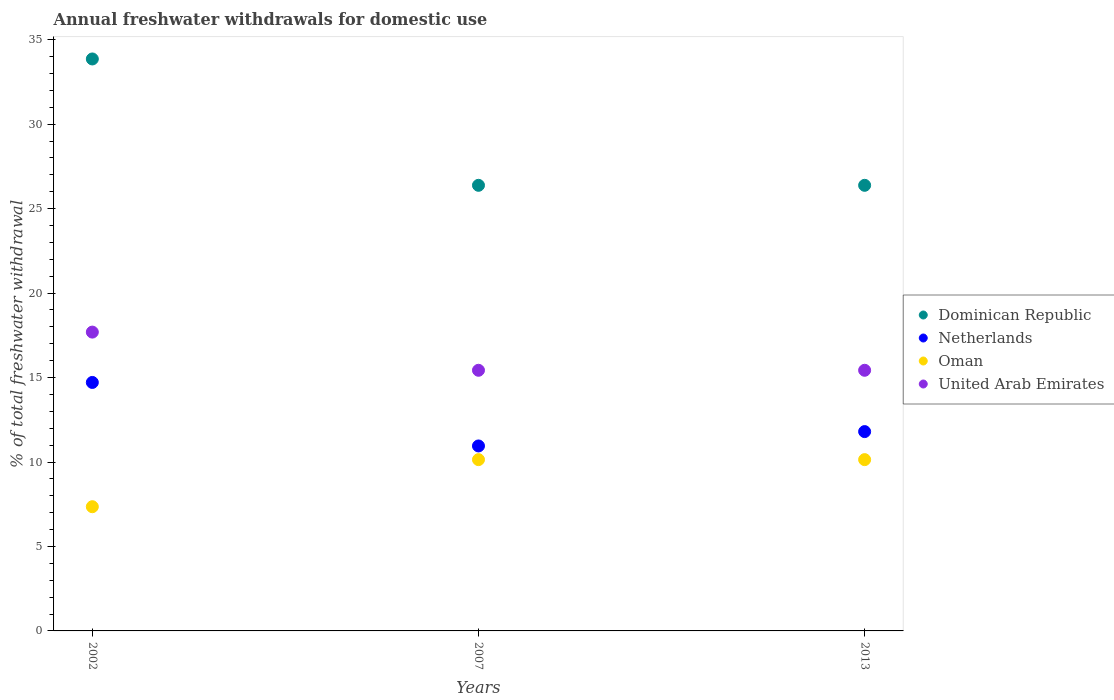Is the number of dotlines equal to the number of legend labels?
Keep it short and to the point. Yes. Across all years, what is the maximum total annual withdrawals from freshwater in Dominican Republic?
Ensure brevity in your answer.  33.86. Across all years, what is the minimum total annual withdrawals from freshwater in Dominican Republic?
Provide a short and direct response. 26.38. In which year was the total annual withdrawals from freshwater in Netherlands minimum?
Offer a very short reply. 2007. What is the total total annual withdrawals from freshwater in Oman in the graph?
Provide a short and direct response. 27.63. What is the difference between the total annual withdrawals from freshwater in Oman in 2002 and that in 2007?
Your answer should be very brief. -2.79. What is the difference between the total annual withdrawals from freshwater in United Arab Emirates in 2013 and the total annual withdrawals from freshwater in Dominican Republic in 2007?
Give a very brief answer. -10.95. What is the average total annual withdrawals from freshwater in United Arab Emirates per year?
Offer a very short reply. 16.18. In the year 2013, what is the difference between the total annual withdrawals from freshwater in United Arab Emirates and total annual withdrawals from freshwater in Dominican Republic?
Offer a very short reply. -10.95. What is the ratio of the total annual withdrawals from freshwater in Oman in 2002 to that in 2013?
Your response must be concise. 0.73. What is the difference between the highest and the second highest total annual withdrawals from freshwater in Netherlands?
Ensure brevity in your answer.  2.91. What is the difference between the highest and the lowest total annual withdrawals from freshwater in Dominican Republic?
Offer a terse response. 7.48. In how many years, is the total annual withdrawals from freshwater in Dominican Republic greater than the average total annual withdrawals from freshwater in Dominican Republic taken over all years?
Offer a terse response. 1. Is the sum of the total annual withdrawals from freshwater in Netherlands in 2002 and 2007 greater than the maximum total annual withdrawals from freshwater in United Arab Emirates across all years?
Provide a short and direct response. Yes. Does the total annual withdrawals from freshwater in Oman monotonically increase over the years?
Your response must be concise. No. Is the total annual withdrawals from freshwater in Dominican Republic strictly less than the total annual withdrawals from freshwater in Oman over the years?
Offer a very short reply. No. How many dotlines are there?
Ensure brevity in your answer.  4. Are the values on the major ticks of Y-axis written in scientific E-notation?
Offer a terse response. No. Does the graph contain any zero values?
Your answer should be compact. No. Where does the legend appear in the graph?
Your answer should be compact. Center right. How many legend labels are there?
Keep it short and to the point. 4. What is the title of the graph?
Your response must be concise. Annual freshwater withdrawals for domestic use. What is the label or title of the X-axis?
Your answer should be compact. Years. What is the label or title of the Y-axis?
Ensure brevity in your answer.  % of total freshwater withdrawal. What is the % of total freshwater withdrawal in Dominican Republic in 2002?
Provide a short and direct response. 33.86. What is the % of total freshwater withdrawal of Netherlands in 2002?
Keep it short and to the point. 14.71. What is the % of total freshwater withdrawal in Oman in 2002?
Make the answer very short. 7.35. What is the % of total freshwater withdrawal of United Arab Emirates in 2002?
Give a very brief answer. 17.69. What is the % of total freshwater withdrawal in Dominican Republic in 2007?
Provide a short and direct response. 26.38. What is the % of total freshwater withdrawal in Netherlands in 2007?
Offer a terse response. 10.95. What is the % of total freshwater withdrawal of Oman in 2007?
Provide a short and direct response. 10.14. What is the % of total freshwater withdrawal of United Arab Emirates in 2007?
Make the answer very short. 15.43. What is the % of total freshwater withdrawal in Dominican Republic in 2013?
Provide a short and direct response. 26.38. What is the % of total freshwater withdrawal in Netherlands in 2013?
Offer a very short reply. 11.8. What is the % of total freshwater withdrawal of Oman in 2013?
Your answer should be compact. 10.14. What is the % of total freshwater withdrawal in United Arab Emirates in 2013?
Make the answer very short. 15.43. Across all years, what is the maximum % of total freshwater withdrawal of Dominican Republic?
Keep it short and to the point. 33.86. Across all years, what is the maximum % of total freshwater withdrawal in Netherlands?
Make the answer very short. 14.71. Across all years, what is the maximum % of total freshwater withdrawal of Oman?
Ensure brevity in your answer.  10.14. Across all years, what is the maximum % of total freshwater withdrawal in United Arab Emirates?
Ensure brevity in your answer.  17.69. Across all years, what is the minimum % of total freshwater withdrawal in Dominican Republic?
Offer a very short reply. 26.38. Across all years, what is the minimum % of total freshwater withdrawal in Netherlands?
Ensure brevity in your answer.  10.95. Across all years, what is the minimum % of total freshwater withdrawal of Oman?
Your response must be concise. 7.35. Across all years, what is the minimum % of total freshwater withdrawal in United Arab Emirates?
Give a very brief answer. 15.43. What is the total % of total freshwater withdrawal in Dominican Republic in the graph?
Provide a succinct answer. 86.62. What is the total % of total freshwater withdrawal in Netherlands in the graph?
Ensure brevity in your answer.  37.46. What is the total % of total freshwater withdrawal of Oman in the graph?
Offer a very short reply. 27.63. What is the total % of total freshwater withdrawal in United Arab Emirates in the graph?
Offer a very short reply. 48.55. What is the difference between the % of total freshwater withdrawal of Dominican Republic in 2002 and that in 2007?
Make the answer very short. 7.48. What is the difference between the % of total freshwater withdrawal in Netherlands in 2002 and that in 2007?
Make the answer very short. 3.76. What is the difference between the % of total freshwater withdrawal in Oman in 2002 and that in 2007?
Your answer should be compact. -2.79. What is the difference between the % of total freshwater withdrawal in United Arab Emirates in 2002 and that in 2007?
Keep it short and to the point. 2.26. What is the difference between the % of total freshwater withdrawal of Dominican Republic in 2002 and that in 2013?
Your answer should be very brief. 7.48. What is the difference between the % of total freshwater withdrawal of Netherlands in 2002 and that in 2013?
Give a very brief answer. 2.91. What is the difference between the % of total freshwater withdrawal in Oman in 2002 and that in 2013?
Offer a terse response. -2.79. What is the difference between the % of total freshwater withdrawal of United Arab Emirates in 2002 and that in 2013?
Offer a terse response. 2.26. What is the difference between the % of total freshwater withdrawal in Netherlands in 2007 and that in 2013?
Make the answer very short. -0.85. What is the difference between the % of total freshwater withdrawal in United Arab Emirates in 2007 and that in 2013?
Your response must be concise. 0. What is the difference between the % of total freshwater withdrawal in Dominican Republic in 2002 and the % of total freshwater withdrawal in Netherlands in 2007?
Provide a succinct answer. 22.91. What is the difference between the % of total freshwater withdrawal of Dominican Republic in 2002 and the % of total freshwater withdrawal of Oman in 2007?
Your response must be concise. 23.72. What is the difference between the % of total freshwater withdrawal in Dominican Republic in 2002 and the % of total freshwater withdrawal in United Arab Emirates in 2007?
Keep it short and to the point. 18.43. What is the difference between the % of total freshwater withdrawal in Netherlands in 2002 and the % of total freshwater withdrawal in Oman in 2007?
Make the answer very short. 4.57. What is the difference between the % of total freshwater withdrawal of Netherlands in 2002 and the % of total freshwater withdrawal of United Arab Emirates in 2007?
Make the answer very short. -0.72. What is the difference between the % of total freshwater withdrawal of Oman in 2002 and the % of total freshwater withdrawal of United Arab Emirates in 2007?
Give a very brief answer. -8.08. What is the difference between the % of total freshwater withdrawal of Dominican Republic in 2002 and the % of total freshwater withdrawal of Netherlands in 2013?
Make the answer very short. 22.06. What is the difference between the % of total freshwater withdrawal of Dominican Republic in 2002 and the % of total freshwater withdrawal of Oman in 2013?
Keep it short and to the point. 23.72. What is the difference between the % of total freshwater withdrawal in Dominican Republic in 2002 and the % of total freshwater withdrawal in United Arab Emirates in 2013?
Provide a succinct answer. 18.43. What is the difference between the % of total freshwater withdrawal of Netherlands in 2002 and the % of total freshwater withdrawal of Oman in 2013?
Provide a succinct answer. 4.57. What is the difference between the % of total freshwater withdrawal in Netherlands in 2002 and the % of total freshwater withdrawal in United Arab Emirates in 2013?
Provide a short and direct response. -0.72. What is the difference between the % of total freshwater withdrawal of Oman in 2002 and the % of total freshwater withdrawal of United Arab Emirates in 2013?
Offer a terse response. -8.08. What is the difference between the % of total freshwater withdrawal in Dominican Republic in 2007 and the % of total freshwater withdrawal in Netherlands in 2013?
Offer a terse response. 14.58. What is the difference between the % of total freshwater withdrawal of Dominican Republic in 2007 and the % of total freshwater withdrawal of Oman in 2013?
Ensure brevity in your answer.  16.24. What is the difference between the % of total freshwater withdrawal in Dominican Republic in 2007 and the % of total freshwater withdrawal in United Arab Emirates in 2013?
Provide a succinct answer. 10.95. What is the difference between the % of total freshwater withdrawal in Netherlands in 2007 and the % of total freshwater withdrawal in Oman in 2013?
Offer a very short reply. 0.81. What is the difference between the % of total freshwater withdrawal in Netherlands in 2007 and the % of total freshwater withdrawal in United Arab Emirates in 2013?
Offer a terse response. -4.48. What is the difference between the % of total freshwater withdrawal of Oman in 2007 and the % of total freshwater withdrawal of United Arab Emirates in 2013?
Your response must be concise. -5.29. What is the average % of total freshwater withdrawal of Dominican Republic per year?
Keep it short and to the point. 28.87. What is the average % of total freshwater withdrawal in Netherlands per year?
Give a very brief answer. 12.49. What is the average % of total freshwater withdrawal of Oman per year?
Keep it short and to the point. 9.21. What is the average % of total freshwater withdrawal in United Arab Emirates per year?
Provide a short and direct response. 16.18. In the year 2002, what is the difference between the % of total freshwater withdrawal in Dominican Republic and % of total freshwater withdrawal in Netherlands?
Provide a short and direct response. 19.15. In the year 2002, what is the difference between the % of total freshwater withdrawal of Dominican Republic and % of total freshwater withdrawal of Oman?
Offer a very short reply. 26.51. In the year 2002, what is the difference between the % of total freshwater withdrawal of Dominican Republic and % of total freshwater withdrawal of United Arab Emirates?
Provide a succinct answer. 16.17. In the year 2002, what is the difference between the % of total freshwater withdrawal of Netherlands and % of total freshwater withdrawal of Oman?
Make the answer very short. 7.36. In the year 2002, what is the difference between the % of total freshwater withdrawal of Netherlands and % of total freshwater withdrawal of United Arab Emirates?
Offer a terse response. -2.98. In the year 2002, what is the difference between the % of total freshwater withdrawal in Oman and % of total freshwater withdrawal in United Arab Emirates?
Your answer should be very brief. -10.34. In the year 2007, what is the difference between the % of total freshwater withdrawal in Dominican Republic and % of total freshwater withdrawal in Netherlands?
Ensure brevity in your answer.  15.43. In the year 2007, what is the difference between the % of total freshwater withdrawal in Dominican Republic and % of total freshwater withdrawal in Oman?
Provide a short and direct response. 16.24. In the year 2007, what is the difference between the % of total freshwater withdrawal in Dominican Republic and % of total freshwater withdrawal in United Arab Emirates?
Make the answer very short. 10.95. In the year 2007, what is the difference between the % of total freshwater withdrawal in Netherlands and % of total freshwater withdrawal in Oman?
Make the answer very short. 0.81. In the year 2007, what is the difference between the % of total freshwater withdrawal in Netherlands and % of total freshwater withdrawal in United Arab Emirates?
Your answer should be compact. -4.48. In the year 2007, what is the difference between the % of total freshwater withdrawal in Oman and % of total freshwater withdrawal in United Arab Emirates?
Offer a very short reply. -5.29. In the year 2013, what is the difference between the % of total freshwater withdrawal of Dominican Republic and % of total freshwater withdrawal of Netherlands?
Provide a short and direct response. 14.58. In the year 2013, what is the difference between the % of total freshwater withdrawal in Dominican Republic and % of total freshwater withdrawal in Oman?
Provide a succinct answer. 16.24. In the year 2013, what is the difference between the % of total freshwater withdrawal in Dominican Republic and % of total freshwater withdrawal in United Arab Emirates?
Offer a very short reply. 10.95. In the year 2013, what is the difference between the % of total freshwater withdrawal in Netherlands and % of total freshwater withdrawal in Oman?
Your response must be concise. 1.66. In the year 2013, what is the difference between the % of total freshwater withdrawal of Netherlands and % of total freshwater withdrawal of United Arab Emirates?
Provide a succinct answer. -3.63. In the year 2013, what is the difference between the % of total freshwater withdrawal in Oman and % of total freshwater withdrawal in United Arab Emirates?
Your answer should be compact. -5.29. What is the ratio of the % of total freshwater withdrawal of Dominican Republic in 2002 to that in 2007?
Give a very brief answer. 1.28. What is the ratio of the % of total freshwater withdrawal in Netherlands in 2002 to that in 2007?
Ensure brevity in your answer.  1.34. What is the ratio of the % of total freshwater withdrawal of Oman in 2002 to that in 2007?
Ensure brevity in your answer.  0.73. What is the ratio of the % of total freshwater withdrawal of United Arab Emirates in 2002 to that in 2007?
Your answer should be very brief. 1.15. What is the ratio of the % of total freshwater withdrawal of Dominican Republic in 2002 to that in 2013?
Offer a terse response. 1.28. What is the ratio of the % of total freshwater withdrawal in Netherlands in 2002 to that in 2013?
Your answer should be very brief. 1.25. What is the ratio of the % of total freshwater withdrawal of Oman in 2002 to that in 2013?
Provide a short and direct response. 0.73. What is the ratio of the % of total freshwater withdrawal of United Arab Emirates in 2002 to that in 2013?
Make the answer very short. 1.15. What is the ratio of the % of total freshwater withdrawal of Dominican Republic in 2007 to that in 2013?
Your response must be concise. 1. What is the ratio of the % of total freshwater withdrawal of Netherlands in 2007 to that in 2013?
Ensure brevity in your answer.  0.93. What is the ratio of the % of total freshwater withdrawal in Oman in 2007 to that in 2013?
Provide a succinct answer. 1. What is the difference between the highest and the second highest % of total freshwater withdrawal of Dominican Republic?
Ensure brevity in your answer.  7.48. What is the difference between the highest and the second highest % of total freshwater withdrawal of Netherlands?
Offer a very short reply. 2.91. What is the difference between the highest and the second highest % of total freshwater withdrawal of United Arab Emirates?
Provide a succinct answer. 2.26. What is the difference between the highest and the lowest % of total freshwater withdrawal in Dominican Republic?
Your answer should be compact. 7.48. What is the difference between the highest and the lowest % of total freshwater withdrawal in Netherlands?
Ensure brevity in your answer.  3.76. What is the difference between the highest and the lowest % of total freshwater withdrawal in Oman?
Offer a very short reply. 2.79. What is the difference between the highest and the lowest % of total freshwater withdrawal of United Arab Emirates?
Your response must be concise. 2.26. 